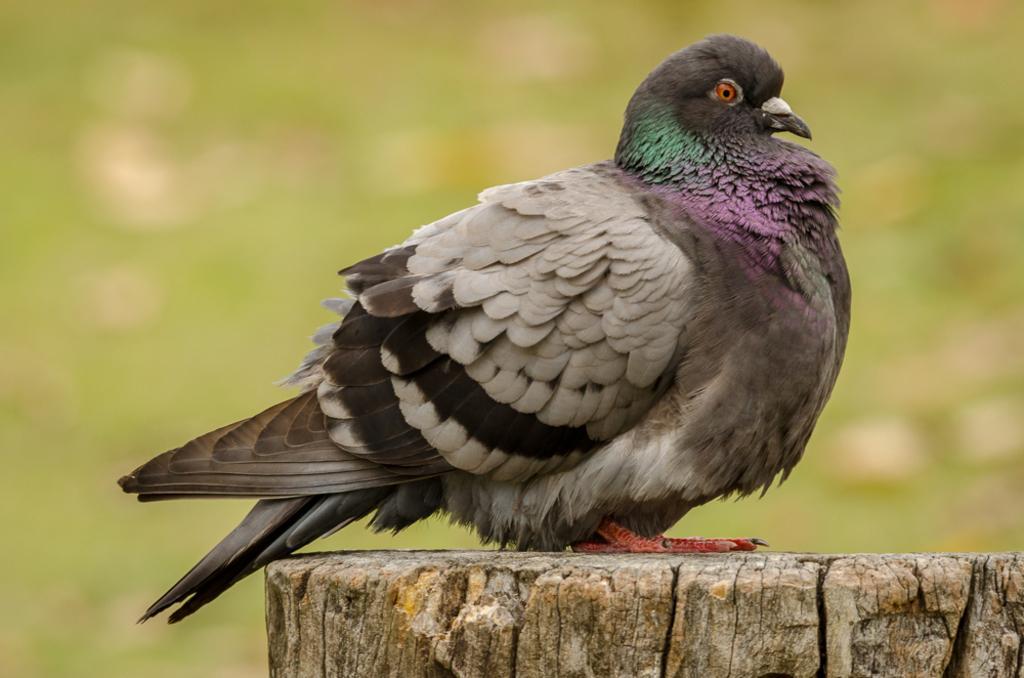How would you summarize this image in a sentence or two? In the image we can see a pigeon, sitting on the wooden trunk and the background is blurred. 